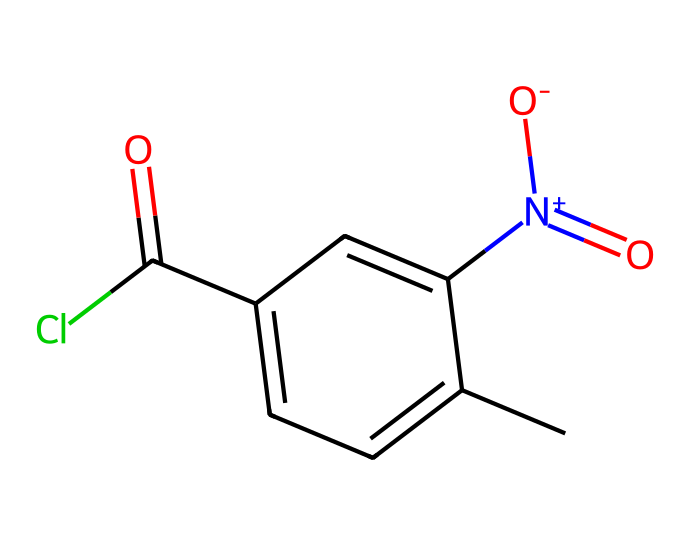What is the chemical name of this structure? The SMILES representation corresponds to the chemical known as 2-chlorobenzalmalononitrile, commonly referred to as CS gas. This is identified by recognizing the structural components indicated in the SMILES.
Answer: CS gas How many carbon atoms are in this molecule? By examining the SMILES representation, we can count the number of carbon atoms present. Each 'C' in the SMILES indicates a carbon atom, and further analysis shows that there are five carbon atoms in the main chain.
Answer: five What functional group is present in this chemical? The SMILES shows a chlorine atom (Cl) attached to the benzene ring and a carbonyl group (C=O) adjacent to a nitrogen group (N+). The presence of the carbonyl group indicates a specific functional group that can be identified as an acyl chloride.
Answer: acyl chloride What type of chemical is CS gas classified as? CS gas is a type of tear gas used primarily for crowd control and is known to be a lachrymatory agent. It is classified as an organic compound, specifically a chemical warfare agent due to its regulation under chemical weapons conventions.
Answer: lachrymatory agent How many nitrogen atoms are in this compound? The SMILES representation contains one nitrogen atom depicted as [N+]. Thus, upon counting, we find that there is a single nitrogen atom present in the structure.
Answer: one What year was CS gas widely adopted for crowd control? CS gas was first synthesized in the 1920s and became widely adopted for crowd control during the 1960s. This adoption reflects its use in police and military applications during civil unrest.
Answer: 1960s 